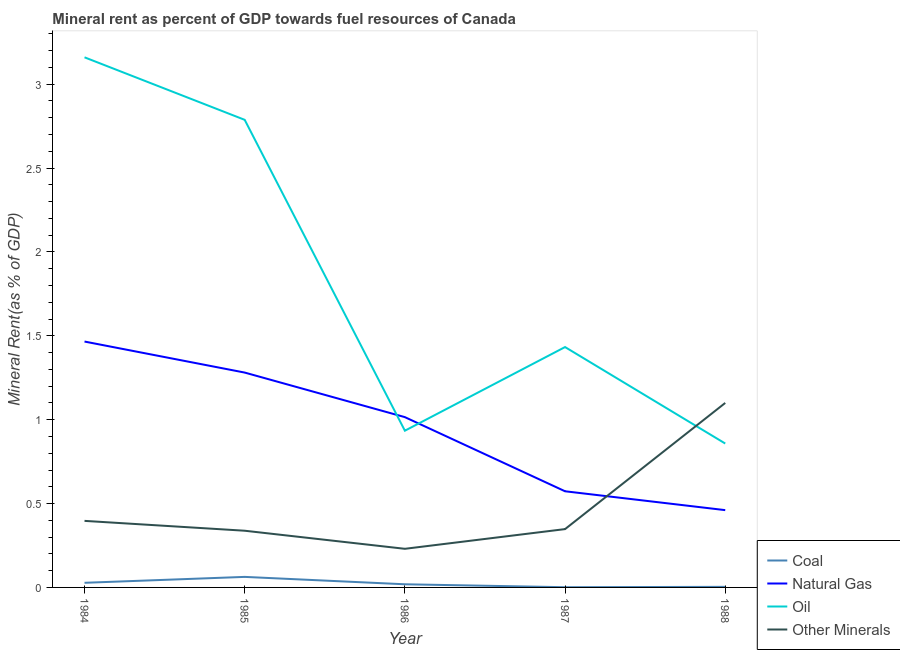Does the line corresponding to natural gas rent intersect with the line corresponding to  rent of other minerals?
Make the answer very short. Yes. Is the number of lines equal to the number of legend labels?
Provide a short and direct response. Yes. What is the coal rent in 1988?
Provide a short and direct response. 0. Across all years, what is the maximum oil rent?
Give a very brief answer. 3.16. Across all years, what is the minimum  rent of other minerals?
Offer a very short reply. 0.23. In which year was the  rent of other minerals minimum?
Provide a short and direct response. 1986. What is the total coal rent in the graph?
Your answer should be compact. 0.11. What is the difference between the natural gas rent in 1986 and that in 1987?
Give a very brief answer. 0.44. What is the difference between the  rent of other minerals in 1988 and the coal rent in 1985?
Your answer should be very brief. 1.04. What is the average coal rent per year?
Provide a succinct answer. 0.02. In the year 1985, what is the difference between the natural gas rent and coal rent?
Offer a terse response. 1.22. What is the ratio of the oil rent in 1984 to that in 1987?
Give a very brief answer. 2.21. What is the difference between the highest and the second highest  rent of other minerals?
Offer a terse response. 0.7. What is the difference between the highest and the lowest oil rent?
Provide a succinct answer. 2.3. Is it the case that in every year, the sum of the coal rent and natural gas rent is greater than the oil rent?
Your answer should be compact. No. Is the  rent of other minerals strictly greater than the coal rent over the years?
Ensure brevity in your answer.  Yes. Is the coal rent strictly less than the natural gas rent over the years?
Give a very brief answer. Yes. How many years are there in the graph?
Your answer should be very brief. 5. What is the difference between two consecutive major ticks on the Y-axis?
Your answer should be very brief. 0.5. Are the values on the major ticks of Y-axis written in scientific E-notation?
Give a very brief answer. No. Does the graph contain any zero values?
Your answer should be very brief. No. How are the legend labels stacked?
Provide a short and direct response. Vertical. What is the title of the graph?
Your answer should be very brief. Mineral rent as percent of GDP towards fuel resources of Canada. What is the label or title of the X-axis?
Offer a terse response. Year. What is the label or title of the Y-axis?
Provide a succinct answer. Mineral Rent(as % of GDP). What is the Mineral Rent(as % of GDP) of Coal in 1984?
Offer a terse response. 0.03. What is the Mineral Rent(as % of GDP) in Natural Gas in 1984?
Offer a very short reply. 1.47. What is the Mineral Rent(as % of GDP) in Oil in 1984?
Provide a short and direct response. 3.16. What is the Mineral Rent(as % of GDP) of Other Minerals in 1984?
Provide a succinct answer. 0.4. What is the Mineral Rent(as % of GDP) in Coal in 1985?
Your answer should be very brief. 0.06. What is the Mineral Rent(as % of GDP) in Natural Gas in 1985?
Make the answer very short. 1.28. What is the Mineral Rent(as % of GDP) in Oil in 1985?
Provide a short and direct response. 2.79. What is the Mineral Rent(as % of GDP) of Other Minerals in 1985?
Offer a terse response. 0.34. What is the Mineral Rent(as % of GDP) in Coal in 1986?
Provide a succinct answer. 0.02. What is the Mineral Rent(as % of GDP) of Natural Gas in 1986?
Keep it short and to the point. 1.02. What is the Mineral Rent(as % of GDP) in Oil in 1986?
Ensure brevity in your answer.  0.93. What is the Mineral Rent(as % of GDP) in Other Minerals in 1986?
Your answer should be compact. 0.23. What is the Mineral Rent(as % of GDP) in Coal in 1987?
Offer a terse response. 0. What is the Mineral Rent(as % of GDP) in Natural Gas in 1987?
Ensure brevity in your answer.  0.57. What is the Mineral Rent(as % of GDP) in Oil in 1987?
Give a very brief answer. 1.43. What is the Mineral Rent(as % of GDP) in Other Minerals in 1987?
Give a very brief answer. 0.35. What is the Mineral Rent(as % of GDP) of Coal in 1988?
Your answer should be compact. 0. What is the Mineral Rent(as % of GDP) in Natural Gas in 1988?
Offer a very short reply. 0.46. What is the Mineral Rent(as % of GDP) of Oil in 1988?
Give a very brief answer. 0.86. What is the Mineral Rent(as % of GDP) in Other Minerals in 1988?
Provide a succinct answer. 1.1. Across all years, what is the maximum Mineral Rent(as % of GDP) in Coal?
Make the answer very short. 0.06. Across all years, what is the maximum Mineral Rent(as % of GDP) of Natural Gas?
Give a very brief answer. 1.47. Across all years, what is the maximum Mineral Rent(as % of GDP) in Oil?
Provide a short and direct response. 3.16. Across all years, what is the maximum Mineral Rent(as % of GDP) of Other Minerals?
Offer a terse response. 1.1. Across all years, what is the minimum Mineral Rent(as % of GDP) in Coal?
Offer a terse response. 0. Across all years, what is the minimum Mineral Rent(as % of GDP) of Natural Gas?
Your answer should be very brief. 0.46. Across all years, what is the minimum Mineral Rent(as % of GDP) of Oil?
Ensure brevity in your answer.  0.86. Across all years, what is the minimum Mineral Rent(as % of GDP) of Other Minerals?
Offer a terse response. 0.23. What is the total Mineral Rent(as % of GDP) of Coal in the graph?
Offer a terse response. 0.11. What is the total Mineral Rent(as % of GDP) of Natural Gas in the graph?
Your answer should be very brief. 4.8. What is the total Mineral Rent(as % of GDP) in Oil in the graph?
Keep it short and to the point. 9.17. What is the total Mineral Rent(as % of GDP) of Other Minerals in the graph?
Offer a very short reply. 2.41. What is the difference between the Mineral Rent(as % of GDP) in Coal in 1984 and that in 1985?
Offer a terse response. -0.04. What is the difference between the Mineral Rent(as % of GDP) of Natural Gas in 1984 and that in 1985?
Make the answer very short. 0.18. What is the difference between the Mineral Rent(as % of GDP) of Oil in 1984 and that in 1985?
Your answer should be very brief. 0.37. What is the difference between the Mineral Rent(as % of GDP) of Other Minerals in 1984 and that in 1985?
Offer a very short reply. 0.06. What is the difference between the Mineral Rent(as % of GDP) of Coal in 1984 and that in 1986?
Provide a succinct answer. 0.01. What is the difference between the Mineral Rent(as % of GDP) of Natural Gas in 1984 and that in 1986?
Your response must be concise. 0.45. What is the difference between the Mineral Rent(as % of GDP) in Oil in 1984 and that in 1986?
Give a very brief answer. 2.23. What is the difference between the Mineral Rent(as % of GDP) in Other Minerals in 1984 and that in 1986?
Your answer should be compact. 0.17. What is the difference between the Mineral Rent(as % of GDP) in Coal in 1984 and that in 1987?
Provide a short and direct response. 0.03. What is the difference between the Mineral Rent(as % of GDP) in Natural Gas in 1984 and that in 1987?
Your answer should be compact. 0.89. What is the difference between the Mineral Rent(as % of GDP) of Oil in 1984 and that in 1987?
Provide a succinct answer. 1.73. What is the difference between the Mineral Rent(as % of GDP) of Other Minerals in 1984 and that in 1987?
Your response must be concise. 0.05. What is the difference between the Mineral Rent(as % of GDP) in Coal in 1984 and that in 1988?
Provide a short and direct response. 0.02. What is the difference between the Mineral Rent(as % of GDP) of Oil in 1984 and that in 1988?
Your response must be concise. 2.3. What is the difference between the Mineral Rent(as % of GDP) in Other Minerals in 1984 and that in 1988?
Make the answer very short. -0.7. What is the difference between the Mineral Rent(as % of GDP) of Coal in 1985 and that in 1986?
Give a very brief answer. 0.04. What is the difference between the Mineral Rent(as % of GDP) in Natural Gas in 1985 and that in 1986?
Ensure brevity in your answer.  0.27. What is the difference between the Mineral Rent(as % of GDP) in Oil in 1985 and that in 1986?
Ensure brevity in your answer.  1.85. What is the difference between the Mineral Rent(as % of GDP) of Other Minerals in 1985 and that in 1986?
Provide a short and direct response. 0.11. What is the difference between the Mineral Rent(as % of GDP) of Coal in 1985 and that in 1987?
Offer a very short reply. 0.06. What is the difference between the Mineral Rent(as % of GDP) in Natural Gas in 1985 and that in 1987?
Offer a very short reply. 0.71. What is the difference between the Mineral Rent(as % of GDP) in Oil in 1985 and that in 1987?
Your response must be concise. 1.35. What is the difference between the Mineral Rent(as % of GDP) in Other Minerals in 1985 and that in 1987?
Ensure brevity in your answer.  -0.01. What is the difference between the Mineral Rent(as % of GDP) of Coal in 1985 and that in 1988?
Offer a very short reply. 0.06. What is the difference between the Mineral Rent(as % of GDP) in Natural Gas in 1985 and that in 1988?
Your answer should be compact. 0.82. What is the difference between the Mineral Rent(as % of GDP) in Oil in 1985 and that in 1988?
Your response must be concise. 1.93. What is the difference between the Mineral Rent(as % of GDP) in Other Minerals in 1985 and that in 1988?
Ensure brevity in your answer.  -0.76. What is the difference between the Mineral Rent(as % of GDP) of Coal in 1986 and that in 1987?
Offer a terse response. 0.02. What is the difference between the Mineral Rent(as % of GDP) of Natural Gas in 1986 and that in 1987?
Give a very brief answer. 0.44. What is the difference between the Mineral Rent(as % of GDP) in Oil in 1986 and that in 1987?
Give a very brief answer. -0.5. What is the difference between the Mineral Rent(as % of GDP) in Other Minerals in 1986 and that in 1987?
Provide a short and direct response. -0.12. What is the difference between the Mineral Rent(as % of GDP) of Coal in 1986 and that in 1988?
Ensure brevity in your answer.  0.02. What is the difference between the Mineral Rent(as % of GDP) in Natural Gas in 1986 and that in 1988?
Provide a short and direct response. 0.55. What is the difference between the Mineral Rent(as % of GDP) of Oil in 1986 and that in 1988?
Ensure brevity in your answer.  0.08. What is the difference between the Mineral Rent(as % of GDP) of Other Minerals in 1986 and that in 1988?
Make the answer very short. -0.87. What is the difference between the Mineral Rent(as % of GDP) of Coal in 1987 and that in 1988?
Make the answer very short. -0. What is the difference between the Mineral Rent(as % of GDP) in Natural Gas in 1987 and that in 1988?
Give a very brief answer. 0.11. What is the difference between the Mineral Rent(as % of GDP) in Oil in 1987 and that in 1988?
Offer a very short reply. 0.58. What is the difference between the Mineral Rent(as % of GDP) of Other Minerals in 1987 and that in 1988?
Your answer should be compact. -0.75. What is the difference between the Mineral Rent(as % of GDP) of Coal in 1984 and the Mineral Rent(as % of GDP) of Natural Gas in 1985?
Give a very brief answer. -1.25. What is the difference between the Mineral Rent(as % of GDP) of Coal in 1984 and the Mineral Rent(as % of GDP) of Oil in 1985?
Your answer should be very brief. -2.76. What is the difference between the Mineral Rent(as % of GDP) in Coal in 1984 and the Mineral Rent(as % of GDP) in Other Minerals in 1985?
Your answer should be compact. -0.31. What is the difference between the Mineral Rent(as % of GDP) of Natural Gas in 1984 and the Mineral Rent(as % of GDP) of Oil in 1985?
Provide a succinct answer. -1.32. What is the difference between the Mineral Rent(as % of GDP) in Natural Gas in 1984 and the Mineral Rent(as % of GDP) in Other Minerals in 1985?
Your response must be concise. 1.13. What is the difference between the Mineral Rent(as % of GDP) of Oil in 1984 and the Mineral Rent(as % of GDP) of Other Minerals in 1985?
Offer a very short reply. 2.82. What is the difference between the Mineral Rent(as % of GDP) of Coal in 1984 and the Mineral Rent(as % of GDP) of Natural Gas in 1986?
Your answer should be compact. -0.99. What is the difference between the Mineral Rent(as % of GDP) of Coal in 1984 and the Mineral Rent(as % of GDP) of Oil in 1986?
Offer a terse response. -0.91. What is the difference between the Mineral Rent(as % of GDP) in Coal in 1984 and the Mineral Rent(as % of GDP) in Other Minerals in 1986?
Your answer should be compact. -0.2. What is the difference between the Mineral Rent(as % of GDP) of Natural Gas in 1984 and the Mineral Rent(as % of GDP) of Oil in 1986?
Your answer should be compact. 0.53. What is the difference between the Mineral Rent(as % of GDP) in Natural Gas in 1984 and the Mineral Rent(as % of GDP) in Other Minerals in 1986?
Keep it short and to the point. 1.24. What is the difference between the Mineral Rent(as % of GDP) of Oil in 1984 and the Mineral Rent(as % of GDP) of Other Minerals in 1986?
Make the answer very short. 2.93. What is the difference between the Mineral Rent(as % of GDP) in Coal in 1984 and the Mineral Rent(as % of GDP) in Natural Gas in 1987?
Your response must be concise. -0.55. What is the difference between the Mineral Rent(as % of GDP) in Coal in 1984 and the Mineral Rent(as % of GDP) in Oil in 1987?
Provide a short and direct response. -1.41. What is the difference between the Mineral Rent(as % of GDP) of Coal in 1984 and the Mineral Rent(as % of GDP) of Other Minerals in 1987?
Keep it short and to the point. -0.32. What is the difference between the Mineral Rent(as % of GDP) in Natural Gas in 1984 and the Mineral Rent(as % of GDP) in Oil in 1987?
Your answer should be compact. 0.03. What is the difference between the Mineral Rent(as % of GDP) in Natural Gas in 1984 and the Mineral Rent(as % of GDP) in Other Minerals in 1987?
Your response must be concise. 1.12. What is the difference between the Mineral Rent(as % of GDP) of Oil in 1984 and the Mineral Rent(as % of GDP) of Other Minerals in 1987?
Your response must be concise. 2.81. What is the difference between the Mineral Rent(as % of GDP) of Coal in 1984 and the Mineral Rent(as % of GDP) of Natural Gas in 1988?
Make the answer very short. -0.43. What is the difference between the Mineral Rent(as % of GDP) in Coal in 1984 and the Mineral Rent(as % of GDP) in Oil in 1988?
Provide a short and direct response. -0.83. What is the difference between the Mineral Rent(as % of GDP) of Coal in 1984 and the Mineral Rent(as % of GDP) of Other Minerals in 1988?
Your answer should be compact. -1.07. What is the difference between the Mineral Rent(as % of GDP) in Natural Gas in 1984 and the Mineral Rent(as % of GDP) in Oil in 1988?
Provide a succinct answer. 0.61. What is the difference between the Mineral Rent(as % of GDP) of Natural Gas in 1984 and the Mineral Rent(as % of GDP) of Other Minerals in 1988?
Offer a very short reply. 0.37. What is the difference between the Mineral Rent(as % of GDP) of Oil in 1984 and the Mineral Rent(as % of GDP) of Other Minerals in 1988?
Give a very brief answer. 2.06. What is the difference between the Mineral Rent(as % of GDP) of Coal in 1985 and the Mineral Rent(as % of GDP) of Natural Gas in 1986?
Your response must be concise. -0.95. What is the difference between the Mineral Rent(as % of GDP) in Coal in 1985 and the Mineral Rent(as % of GDP) in Oil in 1986?
Ensure brevity in your answer.  -0.87. What is the difference between the Mineral Rent(as % of GDP) in Coal in 1985 and the Mineral Rent(as % of GDP) in Other Minerals in 1986?
Make the answer very short. -0.17. What is the difference between the Mineral Rent(as % of GDP) in Natural Gas in 1985 and the Mineral Rent(as % of GDP) in Oil in 1986?
Provide a succinct answer. 0.35. What is the difference between the Mineral Rent(as % of GDP) in Natural Gas in 1985 and the Mineral Rent(as % of GDP) in Other Minerals in 1986?
Make the answer very short. 1.05. What is the difference between the Mineral Rent(as % of GDP) of Oil in 1985 and the Mineral Rent(as % of GDP) of Other Minerals in 1986?
Ensure brevity in your answer.  2.56. What is the difference between the Mineral Rent(as % of GDP) of Coal in 1985 and the Mineral Rent(as % of GDP) of Natural Gas in 1987?
Your answer should be compact. -0.51. What is the difference between the Mineral Rent(as % of GDP) of Coal in 1985 and the Mineral Rent(as % of GDP) of Oil in 1987?
Your response must be concise. -1.37. What is the difference between the Mineral Rent(as % of GDP) in Coal in 1985 and the Mineral Rent(as % of GDP) in Other Minerals in 1987?
Provide a succinct answer. -0.28. What is the difference between the Mineral Rent(as % of GDP) of Natural Gas in 1985 and the Mineral Rent(as % of GDP) of Oil in 1987?
Offer a very short reply. -0.15. What is the difference between the Mineral Rent(as % of GDP) of Natural Gas in 1985 and the Mineral Rent(as % of GDP) of Other Minerals in 1987?
Keep it short and to the point. 0.93. What is the difference between the Mineral Rent(as % of GDP) of Oil in 1985 and the Mineral Rent(as % of GDP) of Other Minerals in 1987?
Provide a short and direct response. 2.44. What is the difference between the Mineral Rent(as % of GDP) in Coal in 1985 and the Mineral Rent(as % of GDP) in Natural Gas in 1988?
Make the answer very short. -0.4. What is the difference between the Mineral Rent(as % of GDP) in Coal in 1985 and the Mineral Rent(as % of GDP) in Oil in 1988?
Provide a short and direct response. -0.8. What is the difference between the Mineral Rent(as % of GDP) of Coal in 1985 and the Mineral Rent(as % of GDP) of Other Minerals in 1988?
Provide a succinct answer. -1.04. What is the difference between the Mineral Rent(as % of GDP) of Natural Gas in 1985 and the Mineral Rent(as % of GDP) of Oil in 1988?
Your response must be concise. 0.42. What is the difference between the Mineral Rent(as % of GDP) in Natural Gas in 1985 and the Mineral Rent(as % of GDP) in Other Minerals in 1988?
Give a very brief answer. 0.18. What is the difference between the Mineral Rent(as % of GDP) of Oil in 1985 and the Mineral Rent(as % of GDP) of Other Minerals in 1988?
Offer a very short reply. 1.69. What is the difference between the Mineral Rent(as % of GDP) of Coal in 1986 and the Mineral Rent(as % of GDP) of Natural Gas in 1987?
Your answer should be very brief. -0.55. What is the difference between the Mineral Rent(as % of GDP) in Coal in 1986 and the Mineral Rent(as % of GDP) in Oil in 1987?
Give a very brief answer. -1.41. What is the difference between the Mineral Rent(as % of GDP) in Coal in 1986 and the Mineral Rent(as % of GDP) in Other Minerals in 1987?
Your answer should be compact. -0.33. What is the difference between the Mineral Rent(as % of GDP) in Natural Gas in 1986 and the Mineral Rent(as % of GDP) in Oil in 1987?
Provide a short and direct response. -0.42. What is the difference between the Mineral Rent(as % of GDP) of Natural Gas in 1986 and the Mineral Rent(as % of GDP) of Other Minerals in 1987?
Provide a succinct answer. 0.67. What is the difference between the Mineral Rent(as % of GDP) in Oil in 1986 and the Mineral Rent(as % of GDP) in Other Minerals in 1987?
Provide a succinct answer. 0.59. What is the difference between the Mineral Rent(as % of GDP) of Coal in 1986 and the Mineral Rent(as % of GDP) of Natural Gas in 1988?
Give a very brief answer. -0.44. What is the difference between the Mineral Rent(as % of GDP) of Coal in 1986 and the Mineral Rent(as % of GDP) of Oil in 1988?
Your answer should be compact. -0.84. What is the difference between the Mineral Rent(as % of GDP) of Coal in 1986 and the Mineral Rent(as % of GDP) of Other Minerals in 1988?
Your answer should be compact. -1.08. What is the difference between the Mineral Rent(as % of GDP) of Natural Gas in 1986 and the Mineral Rent(as % of GDP) of Oil in 1988?
Your answer should be compact. 0.16. What is the difference between the Mineral Rent(as % of GDP) in Natural Gas in 1986 and the Mineral Rent(as % of GDP) in Other Minerals in 1988?
Make the answer very short. -0.08. What is the difference between the Mineral Rent(as % of GDP) of Oil in 1986 and the Mineral Rent(as % of GDP) of Other Minerals in 1988?
Make the answer very short. -0.17. What is the difference between the Mineral Rent(as % of GDP) of Coal in 1987 and the Mineral Rent(as % of GDP) of Natural Gas in 1988?
Your answer should be compact. -0.46. What is the difference between the Mineral Rent(as % of GDP) of Coal in 1987 and the Mineral Rent(as % of GDP) of Oil in 1988?
Give a very brief answer. -0.86. What is the difference between the Mineral Rent(as % of GDP) of Coal in 1987 and the Mineral Rent(as % of GDP) of Other Minerals in 1988?
Provide a short and direct response. -1.1. What is the difference between the Mineral Rent(as % of GDP) in Natural Gas in 1987 and the Mineral Rent(as % of GDP) in Oil in 1988?
Your answer should be very brief. -0.28. What is the difference between the Mineral Rent(as % of GDP) of Natural Gas in 1987 and the Mineral Rent(as % of GDP) of Other Minerals in 1988?
Your response must be concise. -0.53. What is the difference between the Mineral Rent(as % of GDP) in Oil in 1987 and the Mineral Rent(as % of GDP) in Other Minerals in 1988?
Provide a succinct answer. 0.33. What is the average Mineral Rent(as % of GDP) of Coal per year?
Provide a short and direct response. 0.02. What is the average Mineral Rent(as % of GDP) in Natural Gas per year?
Make the answer very short. 0.96. What is the average Mineral Rent(as % of GDP) of Oil per year?
Keep it short and to the point. 1.83. What is the average Mineral Rent(as % of GDP) of Other Minerals per year?
Ensure brevity in your answer.  0.48. In the year 1984, what is the difference between the Mineral Rent(as % of GDP) in Coal and Mineral Rent(as % of GDP) in Natural Gas?
Your answer should be very brief. -1.44. In the year 1984, what is the difference between the Mineral Rent(as % of GDP) of Coal and Mineral Rent(as % of GDP) of Oil?
Offer a very short reply. -3.13. In the year 1984, what is the difference between the Mineral Rent(as % of GDP) in Coal and Mineral Rent(as % of GDP) in Other Minerals?
Your answer should be very brief. -0.37. In the year 1984, what is the difference between the Mineral Rent(as % of GDP) of Natural Gas and Mineral Rent(as % of GDP) of Oil?
Your answer should be compact. -1.69. In the year 1984, what is the difference between the Mineral Rent(as % of GDP) of Natural Gas and Mineral Rent(as % of GDP) of Other Minerals?
Make the answer very short. 1.07. In the year 1984, what is the difference between the Mineral Rent(as % of GDP) of Oil and Mineral Rent(as % of GDP) of Other Minerals?
Provide a short and direct response. 2.76. In the year 1985, what is the difference between the Mineral Rent(as % of GDP) in Coal and Mineral Rent(as % of GDP) in Natural Gas?
Give a very brief answer. -1.22. In the year 1985, what is the difference between the Mineral Rent(as % of GDP) of Coal and Mineral Rent(as % of GDP) of Oil?
Give a very brief answer. -2.72. In the year 1985, what is the difference between the Mineral Rent(as % of GDP) in Coal and Mineral Rent(as % of GDP) in Other Minerals?
Your response must be concise. -0.28. In the year 1985, what is the difference between the Mineral Rent(as % of GDP) of Natural Gas and Mineral Rent(as % of GDP) of Oil?
Provide a short and direct response. -1.51. In the year 1985, what is the difference between the Mineral Rent(as % of GDP) in Natural Gas and Mineral Rent(as % of GDP) in Other Minerals?
Your response must be concise. 0.94. In the year 1985, what is the difference between the Mineral Rent(as % of GDP) of Oil and Mineral Rent(as % of GDP) of Other Minerals?
Give a very brief answer. 2.45. In the year 1986, what is the difference between the Mineral Rent(as % of GDP) in Coal and Mineral Rent(as % of GDP) in Natural Gas?
Keep it short and to the point. -1. In the year 1986, what is the difference between the Mineral Rent(as % of GDP) of Coal and Mineral Rent(as % of GDP) of Oil?
Provide a succinct answer. -0.92. In the year 1986, what is the difference between the Mineral Rent(as % of GDP) in Coal and Mineral Rent(as % of GDP) in Other Minerals?
Make the answer very short. -0.21. In the year 1986, what is the difference between the Mineral Rent(as % of GDP) in Natural Gas and Mineral Rent(as % of GDP) in Oil?
Ensure brevity in your answer.  0.08. In the year 1986, what is the difference between the Mineral Rent(as % of GDP) in Natural Gas and Mineral Rent(as % of GDP) in Other Minerals?
Keep it short and to the point. 0.79. In the year 1986, what is the difference between the Mineral Rent(as % of GDP) of Oil and Mineral Rent(as % of GDP) of Other Minerals?
Make the answer very short. 0.7. In the year 1987, what is the difference between the Mineral Rent(as % of GDP) in Coal and Mineral Rent(as % of GDP) in Natural Gas?
Provide a short and direct response. -0.57. In the year 1987, what is the difference between the Mineral Rent(as % of GDP) of Coal and Mineral Rent(as % of GDP) of Oil?
Offer a terse response. -1.43. In the year 1987, what is the difference between the Mineral Rent(as % of GDP) in Coal and Mineral Rent(as % of GDP) in Other Minerals?
Offer a terse response. -0.35. In the year 1987, what is the difference between the Mineral Rent(as % of GDP) of Natural Gas and Mineral Rent(as % of GDP) of Oil?
Make the answer very short. -0.86. In the year 1987, what is the difference between the Mineral Rent(as % of GDP) in Natural Gas and Mineral Rent(as % of GDP) in Other Minerals?
Provide a succinct answer. 0.23. In the year 1987, what is the difference between the Mineral Rent(as % of GDP) in Oil and Mineral Rent(as % of GDP) in Other Minerals?
Give a very brief answer. 1.09. In the year 1988, what is the difference between the Mineral Rent(as % of GDP) in Coal and Mineral Rent(as % of GDP) in Natural Gas?
Ensure brevity in your answer.  -0.46. In the year 1988, what is the difference between the Mineral Rent(as % of GDP) in Coal and Mineral Rent(as % of GDP) in Oil?
Your answer should be very brief. -0.85. In the year 1988, what is the difference between the Mineral Rent(as % of GDP) of Coal and Mineral Rent(as % of GDP) of Other Minerals?
Give a very brief answer. -1.1. In the year 1988, what is the difference between the Mineral Rent(as % of GDP) in Natural Gas and Mineral Rent(as % of GDP) in Oil?
Offer a very short reply. -0.4. In the year 1988, what is the difference between the Mineral Rent(as % of GDP) of Natural Gas and Mineral Rent(as % of GDP) of Other Minerals?
Your response must be concise. -0.64. In the year 1988, what is the difference between the Mineral Rent(as % of GDP) of Oil and Mineral Rent(as % of GDP) of Other Minerals?
Offer a terse response. -0.24. What is the ratio of the Mineral Rent(as % of GDP) of Coal in 1984 to that in 1985?
Provide a succinct answer. 0.44. What is the ratio of the Mineral Rent(as % of GDP) of Natural Gas in 1984 to that in 1985?
Your answer should be very brief. 1.14. What is the ratio of the Mineral Rent(as % of GDP) of Oil in 1984 to that in 1985?
Offer a terse response. 1.13. What is the ratio of the Mineral Rent(as % of GDP) of Other Minerals in 1984 to that in 1985?
Offer a very short reply. 1.17. What is the ratio of the Mineral Rent(as % of GDP) in Coal in 1984 to that in 1986?
Provide a succinct answer. 1.47. What is the ratio of the Mineral Rent(as % of GDP) of Natural Gas in 1984 to that in 1986?
Make the answer very short. 1.44. What is the ratio of the Mineral Rent(as % of GDP) in Oil in 1984 to that in 1986?
Keep it short and to the point. 3.38. What is the ratio of the Mineral Rent(as % of GDP) of Other Minerals in 1984 to that in 1986?
Offer a very short reply. 1.72. What is the ratio of the Mineral Rent(as % of GDP) of Coal in 1984 to that in 1987?
Provide a succinct answer. 20.92. What is the ratio of the Mineral Rent(as % of GDP) in Natural Gas in 1984 to that in 1987?
Your answer should be compact. 2.56. What is the ratio of the Mineral Rent(as % of GDP) in Oil in 1984 to that in 1987?
Make the answer very short. 2.21. What is the ratio of the Mineral Rent(as % of GDP) of Other Minerals in 1984 to that in 1987?
Make the answer very short. 1.14. What is the ratio of the Mineral Rent(as % of GDP) in Coal in 1984 to that in 1988?
Ensure brevity in your answer.  7.95. What is the ratio of the Mineral Rent(as % of GDP) in Natural Gas in 1984 to that in 1988?
Offer a very short reply. 3.18. What is the ratio of the Mineral Rent(as % of GDP) in Oil in 1984 to that in 1988?
Provide a succinct answer. 3.68. What is the ratio of the Mineral Rent(as % of GDP) in Other Minerals in 1984 to that in 1988?
Offer a terse response. 0.36. What is the ratio of the Mineral Rent(as % of GDP) of Coal in 1985 to that in 1986?
Ensure brevity in your answer.  3.35. What is the ratio of the Mineral Rent(as % of GDP) in Natural Gas in 1985 to that in 1986?
Make the answer very short. 1.26. What is the ratio of the Mineral Rent(as % of GDP) in Oil in 1985 to that in 1986?
Ensure brevity in your answer.  2.98. What is the ratio of the Mineral Rent(as % of GDP) of Other Minerals in 1985 to that in 1986?
Ensure brevity in your answer.  1.47. What is the ratio of the Mineral Rent(as % of GDP) of Coal in 1985 to that in 1987?
Provide a short and direct response. 47.6. What is the ratio of the Mineral Rent(as % of GDP) in Natural Gas in 1985 to that in 1987?
Offer a very short reply. 2.23. What is the ratio of the Mineral Rent(as % of GDP) of Oil in 1985 to that in 1987?
Offer a very short reply. 1.95. What is the ratio of the Mineral Rent(as % of GDP) of Other Minerals in 1985 to that in 1987?
Your answer should be very brief. 0.97. What is the ratio of the Mineral Rent(as % of GDP) in Coal in 1985 to that in 1988?
Your answer should be very brief. 18.08. What is the ratio of the Mineral Rent(as % of GDP) of Natural Gas in 1985 to that in 1988?
Keep it short and to the point. 2.78. What is the ratio of the Mineral Rent(as % of GDP) in Oil in 1985 to that in 1988?
Make the answer very short. 3.25. What is the ratio of the Mineral Rent(as % of GDP) of Other Minerals in 1985 to that in 1988?
Offer a terse response. 0.31. What is the ratio of the Mineral Rent(as % of GDP) in Coal in 1986 to that in 1987?
Give a very brief answer. 14.2. What is the ratio of the Mineral Rent(as % of GDP) of Natural Gas in 1986 to that in 1987?
Your answer should be compact. 1.77. What is the ratio of the Mineral Rent(as % of GDP) of Oil in 1986 to that in 1987?
Make the answer very short. 0.65. What is the ratio of the Mineral Rent(as % of GDP) in Other Minerals in 1986 to that in 1987?
Provide a short and direct response. 0.66. What is the ratio of the Mineral Rent(as % of GDP) of Coal in 1986 to that in 1988?
Ensure brevity in your answer.  5.39. What is the ratio of the Mineral Rent(as % of GDP) in Natural Gas in 1986 to that in 1988?
Your response must be concise. 2.2. What is the ratio of the Mineral Rent(as % of GDP) of Oil in 1986 to that in 1988?
Keep it short and to the point. 1.09. What is the ratio of the Mineral Rent(as % of GDP) in Other Minerals in 1986 to that in 1988?
Ensure brevity in your answer.  0.21. What is the ratio of the Mineral Rent(as % of GDP) of Coal in 1987 to that in 1988?
Make the answer very short. 0.38. What is the ratio of the Mineral Rent(as % of GDP) of Natural Gas in 1987 to that in 1988?
Your answer should be compact. 1.24. What is the ratio of the Mineral Rent(as % of GDP) in Oil in 1987 to that in 1988?
Your answer should be compact. 1.67. What is the ratio of the Mineral Rent(as % of GDP) of Other Minerals in 1987 to that in 1988?
Your answer should be very brief. 0.32. What is the difference between the highest and the second highest Mineral Rent(as % of GDP) in Coal?
Your answer should be very brief. 0.04. What is the difference between the highest and the second highest Mineral Rent(as % of GDP) in Natural Gas?
Ensure brevity in your answer.  0.18. What is the difference between the highest and the second highest Mineral Rent(as % of GDP) in Oil?
Keep it short and to the point. 0.37. What is the difference between the highest and the second highest Mineral Rent(as % of GDP) in Other Minerals?
Offer a very short reply. 0.7. What is the difference between the highest and the lowest Mineral Rent(as % of GDP) in Coal?
Make the answer very short. 0.06. What is the difference between the highest and the lowest Mineral Rent(as % of GDP) of Natural Gas?
Offer a very short reply. 1. What is the difference between the highest and the lowest Mineral Rent(as % of GDP) in Oil?
Your response must be concise. 2.3. What is the difference between the highest and the lowest Mineral Rent(as % of GDP) of Other Minerals?
Offer a terse response. 0.87. 